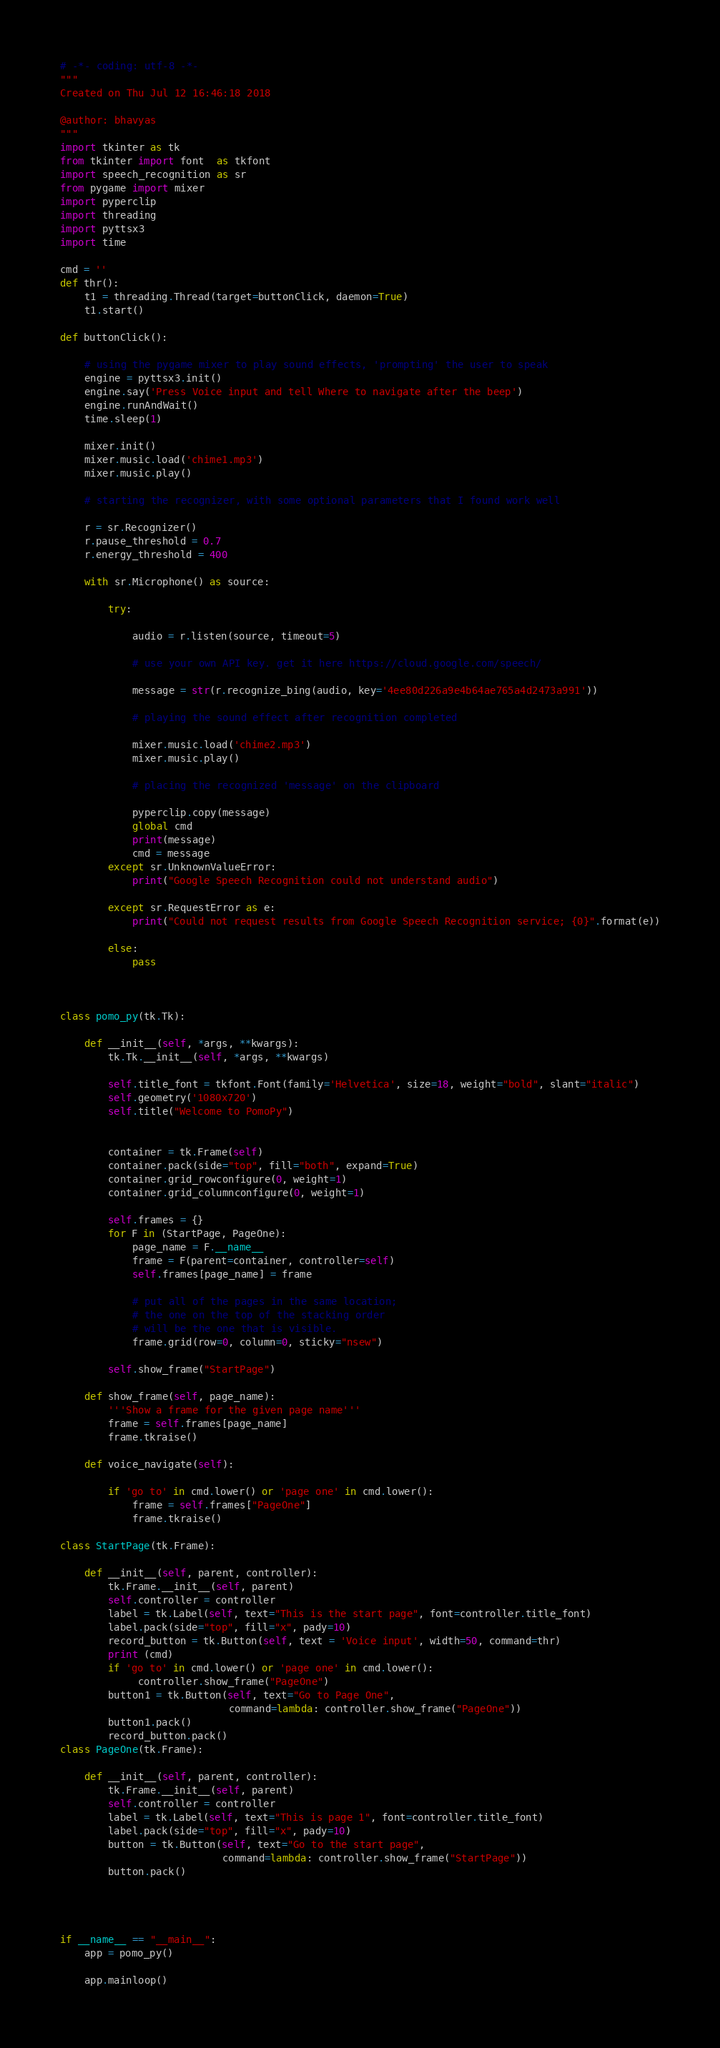Convert code to text. <code><loc_0><loc_0><loc_500><loc_500><_Python_># -*- coding: utf-8 -*-
"""
Created on Thu Jul 12 16:46:18 2018

@author: bhavyas
"""
import tkinter as tk
from tkinter import font  as tkfont
import speech_recognition as sr
from pygame import mixer
import pyperclip
import threading
import pyttsx3
import time

cmd = ''
def thr():
    t1 = threading.Thread(target=buttonClick, daemon=True)
    t1.start()

def buttonClick():

    # using the pygame mixer to play sound effects, 'prompting' the user to speak
    engine = pyttsx3.init()
    engine.say('Press Voice input and tell Where to navigate after the beep')
    engine.runAndWait()
    time.sleep(1)
    
    mixer.init()
    mixer.music.load('chime1.mp3')
    mixer.music.play()

    # starting the recognizer, with some optional parameters that I found work well

    r = sr.Recognizer()                                         
    r.pause_threshold = 0.7                                     
    r.energy_threshold = 400
    
    with sr.Microphone() as source:
        
        try:
            
            audio = r.listen(source, timeout=5)

            # use your own API key. get it here https://cloud.google.com/speech/

            message = str(r.recognize_bing(audio, key='4ee80d226a9e4b64ae765a4d2473a991')) 

            # playing the sound effect after recognition completed 

            mixer.music.load('chime2.mp3')
            mixer.music.play()

            # placing the recognized 'message' on the clipboard

            pyperclip.copy(message)
            global cmd 
            print(message)
            cmd = message
        except sr.UnknownValueError:
            print("Google Speech Recognition could not understand audio")
            
        except sr.RequestError as e:
            print("Could not request results from Google Speech Recognition service; {0}".format(e))

        else:
            pass
        
        

class pomo_py(tk.Tk):

    def __init__(self, *args, **kwargs):
        tk.Tk.__init__(self, *args, **kwargs)

        self.title_font = tkfont.Font(family='Helvetica', size=18, weight="bold", slant="italic")
        self.geometry('1080x720')
        self.title("Welcome to PomoPy")
        
        
        container = tk.Frame(self)
        container.pack(side="top", fill="both", expand=True)
        container.grid_rowconfigure(0, weight=1)
        container.grid_columnconfigure(0, weight=1)
        
        self.frames = {}
        for F in (StartPage, PageOne):
            page_name = F.__name__
            frame = F(parent=container, controller=self)
            self.frames[page_name] = frame

            # put all of the pages in the same location;
            # the one on the top of the stacking order
            # will be the one that is visible.
            frame.grid(row=0, column=0, sticky="nsew")

        self.show_frame("StartPage")

    def show_frame(self, page_name):
        '''Show a frame for the given page name'''
        frame = self.frames[page_name]
        frame.tkraise()
        
    def voice_navigate(self):
       
        if 'go to' in cmd.lower() or 'page one' in cmd.lower():
            frame = self.frames["PageOne"]
            frame.tkraise()
        
class StartPage(tk.Frame):

    def __init__(self, parent, controller):
        tk.Frame.__init__(self, parent)
        self.controller = controller
        label = tk.Label(self, text="This is the start page", font=controller.title_font)
        label.pack(side="top", fill="x", pady=10)
        record_button = tk.Button(self, text = 'Voice input', width=50, command=thr)
        print (cmd)
        if 'go to' in cmd.lower() or 'page one' in cmd.lower():
             controller.show_frame("PageOne")
        button1 = tk.Button(self, text="Go to Page One",
                            command=lambda: controller.show_frame("PageOne"))
        button1.pack()
        record_button.pack()
class PageOne(tk.Frame):

    def __init__(self, parent, controller):
        tk.Frame.__init__(self, parent)
        self.controller = controller
        label = tk.Label(self, text="This is page 1", font=controller.title_font)
        label.pack(side="top", fill="x", pady=10)
        button = tk.Button(self, text="Go to the start page",
                           command=lambda: controller.show_frame("StartPage"))
        button.pack()




if __name__ == "__main__":
    app = pomo_py()
    
    app.mainloop()




</code> 